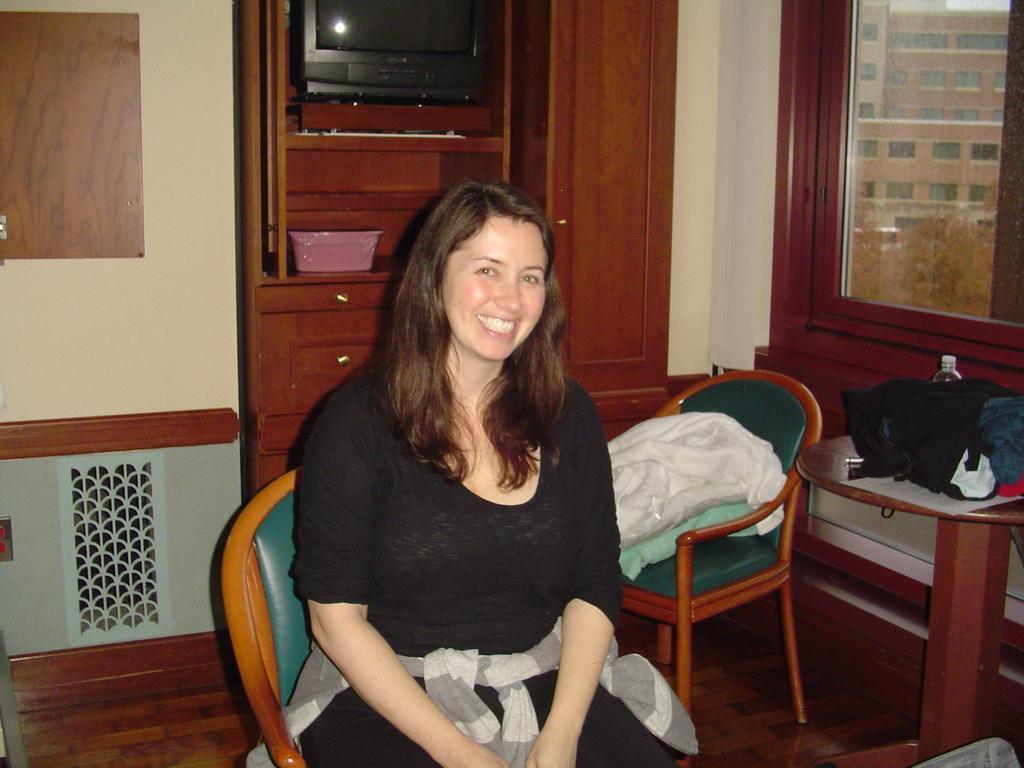Describe this image in one or two sentences. In this picture we can see woman smiling and sitting on chair in the background we can see basket, television, racks, wall on chair we have some items and on table we can see some clothes, bottle, paper and from window we can see buildings, trees. 